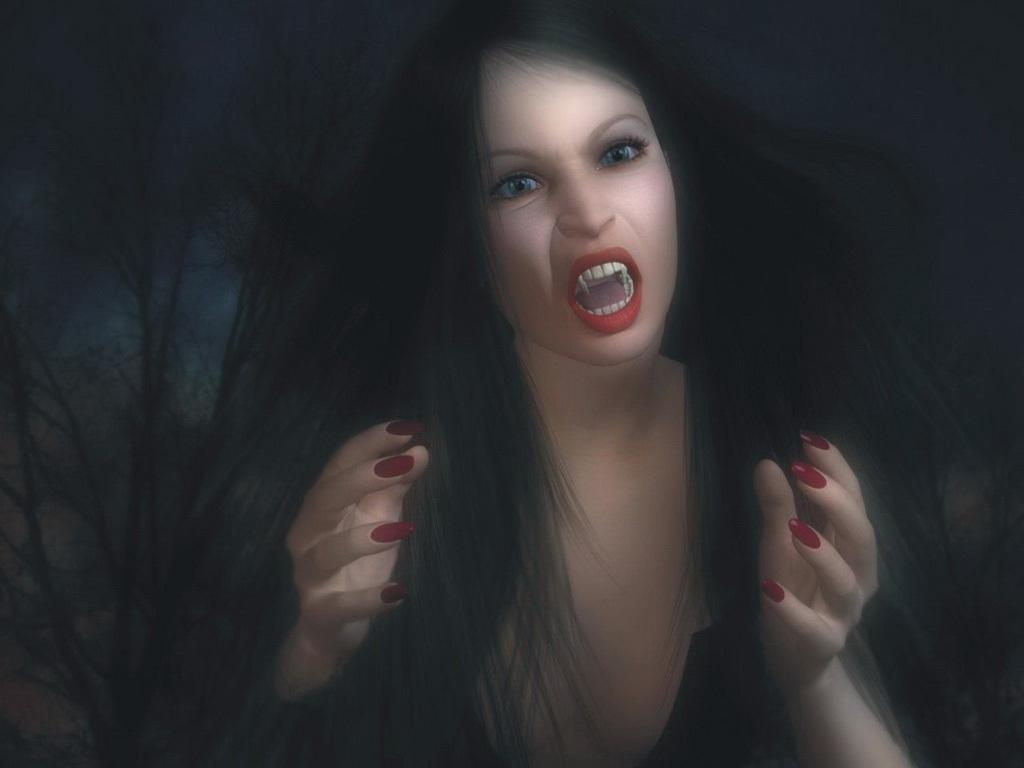What type of image is being described? The image is animated. Who or what is the main subject in the image? There is a woman in the image. What is the woman doing in the image? The woman appears to be shouting. What color is the background of the image? The background of the image is black. How many frogs can be seen on the floor in the image? There are no frogs present in the image, and the floor is not visible in the image. 